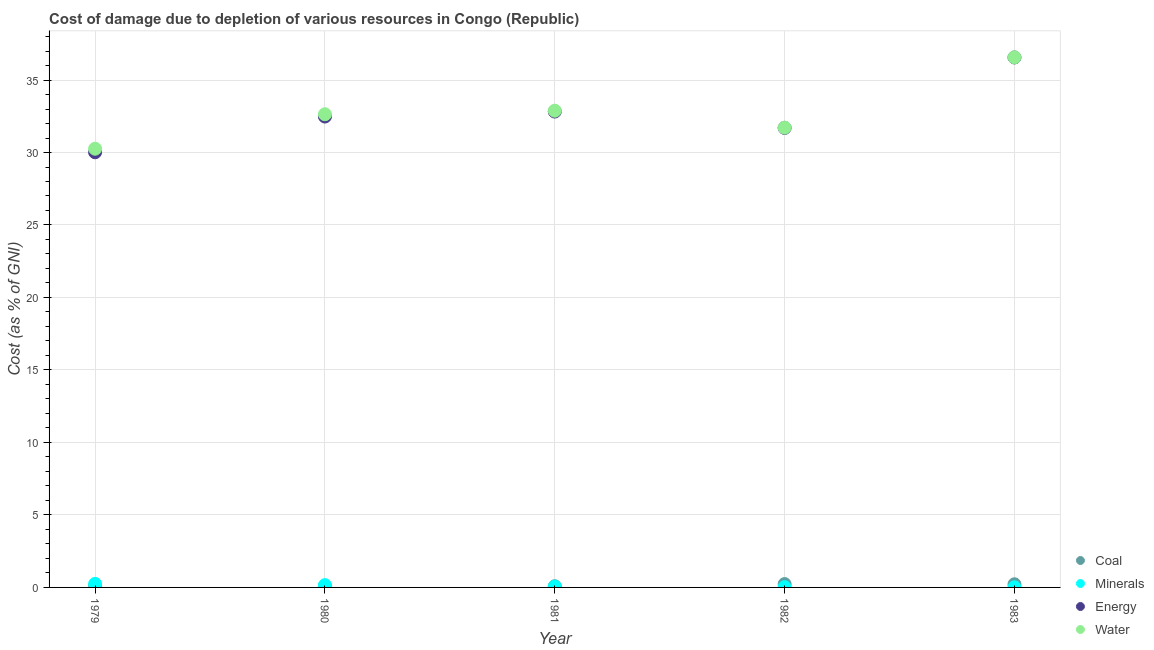What is the cost of damage due to depletion of energy in 1983?
Make the answer very short. 36.56. Across all years, what is the maximum cost of damage due to depletion of water?
Keep it short and to the point. 36.57. Across all years, what is the minimum cost of damage due to depletion of water?
Keep it short and to the point. 30.26. In which year was the cost of damage due to depletion of water minimum?
Ensure brevity in your answer.  1979. What is the total cost of damage due to depletion of coal in the graph?
Give a very brief answer. 0.69. What is the difference between the cost of damage due to depletion of water in 1981 and that in 1983?
Your answer should be compact. -3.68. What is the difference between the cost of damage due to depletion of coal in 1982 and the cost of damage due to depletion of energy in 1981?
Give a very brief answer. -32.59. What is the average cost of damage due to depletion of coal per year?
Provide a short and direct response. 0.14. In the year 1980, what is the difference between the cost of damage due to depletion of minerals and cost of damage due to depletion of coal?
Provide a short and direct response. 0.08. In how many years, is the cost of damage due to depletion of minerals greater than 18 %?
Provide a succinct answer. 0. What is the ratio of the cost of damage due to depletion of energy in 1981 to that in 1983?
Offer a terse response. 0.9. What is the difference between the highest and the second highest cost of damage due to depletion of energy?
Provide a short and direct response. 3.73. What is the difference between the highest and the lowest cost of damage due to depletion of minerals?
Offer a very short reply. 0.23. In how many years, is the cost of damage due to depletion of coal greater than the average cost of damage due to depletion of coal taken over all years?
Offer a very short reply. 2. Is it the case that in every year, the sum of the cost of damage due to depletion of water and cost of damage due to depletion of coal is greater than the sum of cost of damage due to depletion of minerals and cost of damage due to depletion of energy?
Provide a succinct answer. Yes. Is it the case that in every year, the sum of the cost of damage due to depletion of coal and cost of damage due to depletion of minerals is greater than the cost of damage due to depletion of energy?
Provide a succinct answer. No. Is the cost of damage due to depletion of coal strictly greater than the cost of damage due to depletion of energy over the years?
Give a very brief answer. No. How many years are there in the graph?
Ensure brevity in your answer.  5. Are the values on the major ticks of Y-axis written in scientific E-notation?
Keep it short and to the point. No. Where does the legend appear in the graph?
Your response must be concise. Bottom right. How many legend labels are there?
Give a very brief answer. 4. What is the title of the graph?
Ensure brevity in your answer.  Cost of damage due to depletion of various resources in Congo (Republic) . Does "Secondary vocational education" appear as one of the legend labels in the graph?
Provide a succinct answer. No. What is the label or title of the Y-axis?
Your answer should be very brief. Cost (as % of GNI). What is the Cost (as % of GNI) of Coal in 1979?
Give a very brief answer. 0.08. What is the Cost (as % of GNI) in Minerals in 1979?
Your response must be concise. 0.24. What is the Cost (as % of GNI) in Energy in 1979?
Keep it short and to the point. 30.02. What is the Cost (as % of GNI) of Water in 1979?
Ensure brevity in your answer.  30.26. What is the Cost (as % of GNI) in Coal in 1980?
Your answer should be compact. 0.08. What is the Cost (as % of GNI) in Minerals in 1980?
Make the answer very short. 0.16. What is the Cost (as % of GNI) in Energy in 1980?
Make the answer very short. 32.48. What is the Cost (as % of GNI) in Water in 1980?
Your response must be concise. 32.64. What is the Cost (as % of GNI) in Coal in 1981?
Make the answer very short. 0.08. What is the Cost (as % of GNI) of Minerals in 1981?
Keep it short and to the point. 0.06. What is the Cost (as % of GNI) in Energy in 1981?
Offer a very short reply. 32.82. What is the Cost (as % of GNI) of Water in 1981?
Provide a succinct answer. 32.88. What is the Cost (as % of GNI) in Coal in 1982?
Provide a short and direct response. 0.23. What is the Cost (as % of GNI) in Minerals in 1982?
Your answer should be compact. 0.02. What is the Cost (as % of GNI) in Energy in 1982?
Offer a terse response. 31.7. What is the Cost (as % of GNI) of Water in 1982?
Keep it short and to the point. 31.72. What is the Cost (as % of GNI) in Coal in 1983?
Give a very brief answer. 0.22. What is the Cost (as % of GNI) in Minerals in 1983?
Ensure brevity in your answer.  0.01. What is the Cost (as % of GNI) of Energy in 1983?
Provide a short and direct response. 36.56. What is the Cost (as % of GNI) in Water in 1983?
Your answer should be very brief. 36.57. Across all years, what is the maximum Cost (as % of GNI) of Coal?
Ensure brevity in your answer.  0.23. Across all years, what is the maximum Cost (as % of GNI) in Minerals?
Provide a short and direct response. 0.24. Across all years, what is the maximum Cost (as % of GNI) in Energy?
Your answer should be compact. 36.56. Across all years, what is the maximum Cost (as % of GNI) of Water?
Your response must be concise. 36.57. Across all years, what is the minimum Cost (as % of GNI) in Coal?
Your answer should be very brief. 0.08. Across all years, what is the minimum Cost (as % of GNI) of Minerals?
Your answer should be compact. 0.01. Across all years, what is the minimum Cost (as % of GNI) in Energy?
Give a very brief answer. 30.02. Across all years, what is the minimum Cost (as % of GNI) of Water?
Keep it short and to the point. 30.26. What is the total Cost (as % of GNI) in Coal in the graph?
Keep it short and to the point. 0.69. What is the total Cost (as % of GNI) in Minerals in the graph?
Offer a very short reply. 0.49. What is the total Cost (as % of GNI) in Energy in the graph?
Give a very brief answer. 163.57. What is the total Cost (as % of GNI) of Water in the graph?
Your answer should be compact. 164.06. What is the difference between the Cost (as % of GNI) in Coal in 1979 and that in 1980?
Your response must be concise. 0.01. What is the difference between the Cost (as % of GNI) of Minerals in 1979 and that in 1980?
Your answer should be compact. 0.09. What is the difference between the Cost (as % of GNI) in Energy in 1979 and that in 1980?
Your answer should be very brief. -2.46. What is the difference between the Cost (as % of GNI) of Water in 1979 and that in 1980?
Offer a terse response. -2.38. What is the difference between the Cost (as % of GNI) of Coal in 1979 and that in 1981?
Your answer should be very brief. 0. What is the difference between the Cost (as % of GNI) of Minerals in 1979 and that in 1981?
Keep it short and to the point. 0.18. What is the difference between the Cost (as % of GNI) in Energy in 1979 and that in 1981?
Offer a terse response. -2.81. What is the difference between the Cost (as % of GNI) in Water in 1979 and that in 1981?
Provide a succinct answer. -2.62. What is the difference between the Cost (as % of GNI) in Coal in 1979 and that in 1982?
Make the answer very short. -0.15. What is the difference between the Cost (as % of GNI) in Minerals in 1979 and that in 1982?
Your answer should be very brief. 0.22. What is the difference between the Cost (as % of GNI) of Energy in 1979 and that in 1982?
Your response must be concise. -1.68. What is the difference between the Cost (as % of GNI) in Water in 1979 and that in 1982?
Keep it short and to the point. -1.45. What is the difference between the Cost (as % of GNI) in Coal in 1979 and that in 1983?
Make the answer very short. -0.13. What is the difference between the Cost (as % of GNI) of Minerals in 1979 and that in 1983?
Provide a succinct answer. 0.23. What is the difference between the Cost (as % of GNI) of Energy in 1979 and that in 1983?
Provide a succinct answer. -6.54. What is the difference between the Cost (as % of GNI) of Water in 1979 and that in 1983?
Make the answer very short. -6.3. What is the difference between the Cost (as % of GNI) in Coal in 1980 and that in 1981?
Provide a short and direct response. -0. What is the difference between the Cost (as % of GNI) in Minerals in 1980 and that in 1981?
Offer a very short reply. 0.1. What is the difference between the Cost (as % of GNI) of Energy in 1980 and that in 1981?
Offer a very short reply. -0.34. What is the difference between the Cost (as % of GNI) of Water in 1980 and that in 1981?
Make the answer very short. -0.25. What is the difference between the Cost (as % of GNI) in Coal in 1980 and that in 1982?
Give a very brief answer. -0.15. What is the difference between the Cost (as % of GNI) in Minerals in 1980 and that in 1982?
Give a very brief answer. 0.14. What is the difference between the Cost (as % of GNI) of Energy in 1980 and that in 1982?
Your response must be concise. 0.79. What is the difference between the Cost (as % of GNI) in Water in 1980 and that in 1982?
Your response must be concise. 0.92. What is the difference between the Cost (as % of GNI) of Coal in 1980 and that in 1983?
Provide a short and direct response. -0.14. What is the difference between the Cost (as % of GNI) of Minerals in 1980 and that in 1983?
Make the answer very short. 0.15. What is the difference between the Cost (as % of GNI) in Energy in 1980 and that in 1983?
Ensure brevity in your answer.  -4.07. What is the difference between the Cost (as % of GNI) in Water in 1980 and that in 1983?
Make the answer very short. -3.93. What is the difference between the Cost (as % of GNI) of Coal in 1981 and that in 1982?
Provide a short and direct response. -0.15. What is the difference between the Cost (as % of GNI) in Minerals in 1981 and that in 1982?
Offer a terse response. 0.04. What is the difference between the Cost (as % of GNI) of Energy in 1981 and that in 1982?
Your answer should be very brief. 1.13. What is the difference between the Cost (as % of GNI) in Water in 1981 and that in 1982?
Your response must be concise. 1.17. What is the difference between the Cost (as % of GNI) in Coal in 1981 and that in 1983?
Provide a succinct answer. -0.14. What is the difference between the Cost (as % of GNI) of Minerals in 1981 and that in 1983?
Keep it short and to the point. 0.05. What is the difference between the Cost (as % of GNI) of Energy in 1981 and that in 1983?
Your response must be concise. -3.73. What is the difference between the Cost (as % of GNI) in Water in 1981 and that in 1983?
Your answer should be compact. -3.68. What is the difference between the Cost (as % of GNI) of Coal in 1982 and that in 1983?
Provide a short and direct response. 0.01. What is the difference between the Cost (as % of GNI) in Minerals in 1982 and that in 1983?
Keep it short and to the point. 0.01. What is the difference between the Cost (as % of GNI) in Energy in 1982 and that in 1983?
Your answer should be very brief. -4.86. What is the difference between the Cost (as % of GNI) in Water in 1982 and that in 1983?
Your response must be concise. -4.85. What is the difference between the Cost (as % of GNI) in Coal in 1979 and the Cost (as % of GNI) in Minerals in 1980?
Provide a succinct answer. -0.07. What is the difference between the Cost (as % of GNI) in Coal in 1979 and the Cost (as % of GNI) in Energy in 1980?
Make the answer very short. -32.4. What is the difference between the Cost (as % of GNI) in Coal in 1979 and the Cost (as % of GNI) in Water in 1980?
Provide a succinct answer. -32.55. What is the difference between the Cost (as % of GNI) of Minerals in 1979 and the Cost (as % of GNI) of Energy in 1980?
Offer a very short reply. -32.24. What is the difference between the Cost (as % of GNI) of Minerals in 1979 and the Cost (as % of GNI) of Water in 1980?
Make the answer very short. -32.39. What is the difference between the Cost (as % of GNI) of Energy in 1979 and the Cost (as % of GNI) of Water in 1980?
Your answer should be very brief. -2.62. What is the difference between the Cost (as % of GNI) in Coal in 1979 and the Cost (as % of GNI) in Minerals in 1981?
Offer a terse response. 0.02. What is the difference between the Cost (as % of GNI) of Coal in 1979 and the Cost (as % of GNI) of Energy in 1981?
Keep it short and to the point. -32.74. What is the difference between the Cost (as % of GNI) of Coal in 1979 and the Cost (as % of GNI) of Water in 1981?
Offer a very short reply. -32.8. What is the difference between the Cost (as % of GNI) in Minerals in 1979 and the Cost (as % of GNI) in Energy in 1981?
Provide a succinct answer. -32.58. What is the difference between the Cost (as % of GNI) in Minerals in 1979 and the Cost (as % of GNI) in Water in 1981?
Provide a succinct answer. -32.64. What is the difference between the Cost (as % of GNI) in Energy in 1979 and the Cost (as % of GNI) in Water in 1981?
Your response must be concise. -2.87. What is the difference between the Cost (as % of GNI) in Coal in 1979 and the Cost (as % of GNI) in Minerals in 1982?
Your answer should be very brief. 0.06. What is the difference between the Cost (as % of GNI) in Coal in 1979 and the Cost (as % of GNI) in Energy in 1982?
Ensure brevity in your answer.  -31.61. What is the difference between the Cost (as % of GNI) in Coal in 1979 and the Cost (as % of GNI) in Water in 1982?
Give a very brief answer. -31.63. What is the difference between the Cost (as % of GNI) of Minerals in 1979 and the Cost (as % of GNI) of Energy in 1982?
Give a very brief answer. -31.45. What is the difference between the Cost (as % of GNI) in Minerals in 1979 and the Cost (as % of GNI) in Water in 1982?
Your response must be concise. -31.47. What is the difference between the Cost (as % of GNI) in Energy in 1979 and the Cost (as % of GNI) in Water in 1982?
Your response must be concise. -1.7. What is the difference between the Cost (as % of GNI) in Coal in 1979 and the Cost (as % of GNI) in Minerals in 1983?
Your answer should be very brief. 0.07. What is the difference between the Cost (as % of GNI) of Coal in 1979 and the Cost (as % of GNI) of Energy in 1983?
Make the answer very short. -36.47. What is the difference between the Cost (as % of GNI) of Coal in 1979 and the Cost (as % of GNI) of Water in 1983?
Your answer should be compact. -36.48. What is the difference between the Cost (as % of GNI) of Minerals in 1979 and the Cost (as % of GNI) of Energy in 1983?
Offer a terse response. -36.31. What is the difference between the Cost (as % of GNI) of Minerals in 1979 and the Cost (as % of GNI) of Water in 1983?
Offer a very short reply. -36.32. What is the difference between the Cost (as % of GNI) of Energy in 1979 and the Cost (as % of GNI) of Water in 1983?
Your response must be concise. -6.55. What is the difference between the Cost (as % of GNI) in Coal in 1980 and the Cost (as % of GNI) in Minerals in 1981?
Make the answer very short. 0.02. What is the difference between the Cost (as % of GNI) of Coal in 1980 and the Cost (as % of GNI) of Energy in 1981?
Your answer should be compact. -32.75. What is the difference between the Cost (as % of GNI) in Coal in 1980 and the Cost (as % of GNI) in Water in 1981?
Offer a terse response. -32.81. What is the difference between the Cost (as % of GNI) of Minerals in 1980 and the Cost (as % of GNI) of Energy in 1981?
Offer a terse response. -32.67. What is the difference between the Cost (as % of GNI) of Minerals in 1980 and the Cost (as % of GNI) of Water in 1981?
Provide a short and direct response. -32.73. What is the difference between the Cost (as % of GNI) in Energy in 1980 and the Cost (as % of GNI) in Water in 1981?
Offer a terse response. -0.4. What is the difference between the Cost (as % of GNI) in Coal in 1980 and the Cost (as % of GNI) in Minerals in 1982?
Your response must be concise. 0.06. What is the difference between the Cost (as % of GNI) of Coal in 1980 and the Cost (as % of GNI) of Energy in 1982?
Keep it short and to the point. -31.62. What is the difference between the Cost (as % of GNI) in Coal in 1980 and the Cost (as % of GNI) in Water in 1982?
Offer a very short reply. -31.64. What is the difference between the Cost (as % of GNI) in Minerals in 1980 and the Cost (as % of GNI) in Energy in 1982?
Offer a very short reply. -31.54. What is the difference between the Cost (as % of GNI) of Minerals in 1980 and the Cost (as % of GNI) of Water in 1982?
Your answer should be very brief. -31.56. What is the difference between the Cost (as % of GNI) in Energy in 1980 and the Cost (as % of GNI) in Water in 1982?
Give a very brief answer. 0.76. What is the difference between the Cost (as % of GNI) in Coal in 1980 and the Cost (as % of GNI) in Minerals in 1983?
Provide a succinct answer. 0.07. What is the difference between the Cost (as % of GNI) of Coal in 1980 and the Cost (as % of GNI) of Energy in 1983?
Provide a short and direct response. -36.48. What is the difference between the Cost (as % of GNI) in Coal in 1980 and the Cost (as % of GNI) in Water in 1983?
Your answer should be very brief. -36.49. What is the difference between the Cost (as % of GNI) in Minerals in 1980 and the Cost (as % of GNI) in Energy in 1983?
Offer a terse response. -36.4. What is the difference between the Cost (as % of GNI) in Minerals in 1980 and the Cost (as % of GNI) in Water in 1983?
Give a very brief answer. -36.41. What is the difference between the Cost (as % of GNI) in Energy in 1980 and the Cost (as % of GNI) in Water in 1983?
Provide a short and direct response. -4.09. What is the difference between the Cost (as % of GNI) of Coal in 1981 and the Cost (as % of GNI) of Minerals in 1982?
Your answer should be very brief. 0.06. What is the difference between the Cost (as % of GNI) of Coal in 1981 and the Cost (as % of GNI) of Energy in 1982?
Provide a succinct answer. -31.61. What is the difference between the Cost (as % of GNI) in Coal in 1981 and the Cost (as % of GNI) in Water in 1982?
Your response must be concise. -31.63. What is the difference between the Cost (as % of GNI) in Minerals in 1981 and the Cost (as % of GNI) in Energy in 1982?
Offer a very short reply. -31.64. What is the difference between the Cost (as % of GNI) of Minerals in 1981 and the Cost (as % of GNI) of Water in 1982?
Keep it short and to the point. -31.66. What is the difference between the Cost (as % of GNI) of Energy in 1981 and the Cost (as % of GNI) of Water in 1982?
Your response must be concise. 1.11. What is the difference between the Cost (as % of GNI) of Coal in 1981 and the Cost (as % of GNI) of Minerals in 1983?
Your answer should be very brief. 0.07. What is the difference between the Cost (as % of GNI) of Coal in 1981 and the Cost (as % of GNI) of Energy in 1983?
Offer a terse response. -36.47. What is the difference between the Cost (as % of GNI) in Coal in 1981 and the Cost (as % of GNI) in Water in 1983?
Give a very brief answer. -36.48. What is the difference between the Cost (as % of GNI) in Minerals in 1981 and the Cost (as % of GNI) in Energy in 1983?
Give a very brief answer. -36.5. What is the difference between the Cost (as % of GNI) in Minerals in 1981 and the Cost (as % of GNI) in Water in 1983?
Provide a short and direct response. -36.51. What is the difference between the Cost (as % of GNI) in Energy in 1981 and the Cost (as % of GNI) in Water in 1983?
Make the answer very short. -3.74. What is the difference between the Cost (as % of GNI) in Coal in 1982 and the Cost (as % of GNI) in Minerals in 1983?
Give a very brief answer. 0.22. What is the difference between the Cost (as % of GNI) of Coal in 1982 and the Cost (as % of GNI) of Energy in 1983?
Keep it short and to the point. -36.32. What is the difference between the Cost (as % of GNI) in Coal in 1982 and the Cost (as % of GNI) in Water in 1983?
Offer a very short reply. -36.33. What is the difference between the Cost (as % of GNI) of Minerals in 1982 and the Cost (as % of GNI) of Energy in 1983?
Your response must be concise. -36.53. What is the difference between the Cost (as % of GNI) in Minerals in 1982 and the Cost (as % of GNI) in Water in 1983?
Offer a terse response. -36.54. What is the difference between the Cost (as % of GNI) of Energy in 1982 and the Cost (as % of GNI) of Water in 1983?
Offer a terse response. -4.87. What is the average Cost (as % of GNI) of Coal per year?
Offer a very short reply. 0.14. What is the average Cost (as % of GNI) of Minerals per year?
Your answer should be very brief. 0.1. What is the average Cost (as % of GNI) of Energy per year?
Provide a short and direct response. 32.71. What is the average Cost (as % of GNI) of Water per year?
Give a very brief answer. 32.81. In the year 1979, what is the difference between the Cost (as % of GNI) in Coal and Cost (as % of GNI) in Minerals?
Keep it short and to the point. -0.16. In the year 1979, what is the difference between the Cost (as % of GNI) of Coal and Cost (as % of GNI) of Energy?
Your answer should be very brief. -29.93. In the year 1979, what is the difference between the Cost (as % of GNI) of Coal and Cost (as % of GNI) of Water?
Your answer should be very brief. -30.18. In the year 1979, what is the difference between the Cost (as % of GNI) in Minerals and Cost (as % of GNI) in Energy?
Your answer should be very brief. -29.77. In the year 1979, what is the difference between the Cost (as % of GNI) of Minerals and Cost (as % of GNI) of Water?
Give a very brief answer. -30.02. In the year 1979, what is the difference between the Cost (as % of GNI) of Energy and Cost (as % of GNI) of Water?
Your answer should be very brief. -0.24. In the year 1980, what is the difference between the Cost (as % of GNI) of Coal and Cost (as % of GNI) of Minerals?
Your answer should be compact. -0.08. In the year 1980, what is the difference between the Cost (as % of GNI) of Coal and Cost (as % of GNI) of Energy?
Your answer should be compact. -32.4. In the year 1980, what is the difference between the Cost (as % of GNI) of Coal and Cost (as % of GNI) of Water?
Your answer should be very brief. -32.56. In the year 1980, what is the difference between the Cost (as % of GNI) in Minerals and Cost (as % of GNI) in Energy?
Your answer should be very brief. -32.32. In the year 1980, what is the difference between the Cost (as % of GNI) in Minerals and Cost (as % of GNI) in Water?
Provide a short and direct response. -32.48. In the year 1980, what is the difference between the Cost (as % of GNI) in Energy and Cost (as % of GNI) in Water?
Offer a terse response. -0.16. In the year 1981, what is the difference between the Cost (as % of GNI) of Coal and Cost (as % of GNI) of Minerals?
Offer a very short reply. 0.02. In the year 1981, what is the difference between the Cost (as % of GNI) of Coal and Cost (as % of GNI) of Energy?
Provide a short and direct response. -32.74. In the year 1981, what is the difference between the Cost (as % of GNI) of Coal and Cost (as % of GNI) of Water?
Provide a succinct answer. -32.8. In the year 1981, what is the difference between the Cost (as % of GNI) of Minerals and Cost (as % of GNI) of Energy?
Provide a succinct answer. -32.76. In the year 1981, what is the difference between the Cost (as % of GNI) of Minerals and Cost (as % of GNI) of Water?
Your answer should be very brief. -32.82. In the year 1981, what is the difference between the Cost (as % of GNI) of Energy and Cost (as % of GNI) of Water?
Provide a succinct answer. -0.06. In the year 1982, what is the difference between the Cost (as % of GNI) of Coal and Cost (as % of GNI) of Minerals?
Keep it short and to the point. 0.21. In the year 1982, what is the difference between the Cost (as % of GNI) in Coal and Cost (as % of GNI) in Energy?
Keep it short and to the point. -31.46. In the year 1982, what is the difference between the Cost (as % of GNI) of Coal and Cost (as % of GNI) of Water?
Offer a very short reply. -31.48. In the year 1982, what is the difference between the Cost (as % of GNI) of Minerals and Cost (as % of GNI) of Energy?
Provide a short and direct response. -31.67. In the year 1982, what is the difference between the Cost (as % of GNI) in Minerals and Cost (as % of GNI) in Water?
Your answer should be very brief. -31.7. In the year 1982, what is the difference between the Cost (as % of GNI) in Energy and Cost (as % of GNI) in Water?
Keep it short and to the point. -0.02. In the year 1983, what is the difference between the Cost (as % of GNI) of Coal and Cost (as % of GNI) of Minerals?
Your answer should be compact. 0.21. In the year 1983, what is the difference between the Cost (as % of GNI) in Coal and Cost (as % of GNI) in Energy?
Your answer should be compact. -36.34. In the year 1983, what is the difference between the Cost (as % of GNI) in Coal and Cost (as % of GNI) in Water?
Make the answer very short. -36.35. In the year 1983, what is the difference between the Cost (as % of GNI) in Minerals and Cost (as % of GNI) in Energy?
Your answer should be compact. -36.55. In the year 1983, what is the difference between the Cost (as % of GNI) in Minerals and Cost (as % of GNI) in Water?
Offer a terse response. -36.56. In the year 1983, what is the difference between the Cost (as % of GNI) in Energy and Cost (as % of GNI) in Water?
Make the answer very short. -0.01. What is the ratio of the Cost (as % of GNI) in Coal in 1979 to that in 1980?
Ensure brevity in your answer.  1.08. What is the ratio of the Cost (as % of GNI) of Minerals in 1979 to that in 1980?
Offer a terse response. 1.55. What is the ratio of the Cost (as % of GNI) of Energy in 1979 to that in 1980?
Provide a succinct answer. 0.92. What is the ratio of the Cost (as % of GNI) in Water in 1979 to that in 1980?
Your response must be concise. 0.93. What is the ratio of the Cost (as % of GNI) of Coal in 1979 to that in 1981?
Ensure brevity in your answer.  1.03. What is the ratio of the Cost (as % of GNI) in Minerals in 1979 to that in 1981?
Your response must be concise. 4.08. What is the ratio of the Cost (as % of GNI) in Energy in 1979 to that in 1981?
Provide a short and direct response. 0.91. What is the ratio of the Cost (as % of GNI) of Water in 1979 to that in 1981?
Make the answer very short. 0.92. What is the ratio of the Cost (as % of GNI) of Coal in 1979 to that in 1982?
Offer a terse response. 0.36. What is the ratio of the Cost (as % of GNI) of Minerals in 1979 to that in 1982?
Your answer should be very brief. 11.86. What is the ratio of the Cost (as % of GNI) in Energy in 1979 to that in 1982?
Offer a very short reply. 0.95. What is the ratio of the Cost (as % of GNI) of Water in 1979 to that in 1982?
Ensure brevity in your answer.  0.95. What is the ratio of the Cost (as % of GNI) in Coal in 1979 to that in 1983?
Provide a succinct answer. 0.38. What is the ratio of the Cost (as % of GNI) in Minerals in 1979 to that in 1983?
Your answer should be very brief. 23.76. What is the ratio of the Cost (as % of GNI) in Energy in 1979 to that in 1983?
Ensure brevity in your answer.  0.82. What is the ratio of the Cost (as % of GNI) of Water in 1979 to that in 1983?
Your answer should be very brief. 0.83. What is the ratio of the Cost (as % of GNI) in Coal in 1980 to that in 1981?
Provide a short and direct response. 0.95. What is the ratio of the Cost (as % of GNI) of Minerals in 1980 to that in 1981?
Keep it short and to the point. 2.63. What is the ratio of the Cost (as % of GNI) of Water in 1980 to that in 1981?
Make the answer very short. 0.99. What is the ratio of the Cost (as % of GNI) in Coal in 1980 to that in 1982?
Give a very brief answer. 0.33. What is the ratio of the Cost (as % of GNI) of Minerals in 1980 to that in 1982?
Your answer should be compact. 7.65. What is the ratio of the Cost (as % of GNI) of Energy in 1980 to that in 1982?
Keep it short and to the point. 1.02. What is the ratio of the Cost (as % of GNI) in Water in 1980 to that in 1982?
Provide a short and direct response. 1.03. What is the ratio of the Cost (as % of GNI) in Coal in 1980 to that in 1983?
Give a very brief answer. 0.35. What is the ratio of the Cost (as % of GNI) in Minerals in 1980 to that in 1983?
Your answer should be compact. 15.34. What is the ratio of the Cost (as % of GNI) of Energy in 1980 to that in 1983?
Your answer should be compact. 0.89. What is the ratio of the Cost (as % of GNI) of Water in 1980 to that in 1983?
Make the answer very short. 0.89. What is the ratio of the Cost (as % of GNI) in Coal in 1981 to that in 1982?
Make the answer very short. 0.35. What is the ratio of the Cost (as % of GNI) of Minerals in 1981 to that in 1982?
Give a very brief answer. 2.91. What is the ratio of the Cost (as % of GNI) of Energy in 1981 to that in 1982?
Ensure brevity in your answer.  1.04. What is the ratio of the Cost (as % of GNI) in Water in 1981 to that in 1982?
Your answer should be very brief. 1.04. What is the ratio of the Cost (as % of GNI) of Coal in 1981 to that in 1983?
Your answer should be compact. 0.37. What is the ratio of the Cost (as % of GNI) in Minerals in 1981 to that in 1983?
Provide a succinct answer. 5.82. What is the ratio of the Cost (as % of GNI) in Energy in 1981 to that in 1983?
Keep it short and to the point. 0.9. What is the ratio of the Cost (as % of GNI) in Water in 1981 to that in 1983?
Give a very brief answer. 0.9. What is the ratio of the Cost (as % of GNI) of Coal in 1982 to that in 1983?
Provide a succinct answer. 1.06. What is the ratio of the Cost (as % of GNI) in Minerals in 1982 to that in 1983?
Your answer should be compact. 2. What is the ratio of the Cost (as % of GNI) of Energy in 1982 to that in 1983?
Offer a very short reply. 0.87. What is the ratio of the Cost (as % of GNI) in Water in 1982 to that in 1983?
Make the answer very short. 0.87. What is the difference between the highest and the second highest Cost (as % of GNI) of Coal?
Make the answer very short. 0.01. What is the difference between the highest and the second highest Cost (as % of GNI) of Minerals?
Provide a short and direct response. 0.09. What is the difference between the highest and the second highest Cost (as % of GNI) in Energy?
Offer a terse response. 3.73. What is the difference between the highest and the second highest Cost (as % of GNI) in Water?
Ensure brevity in your answer.  3.68. What is the difference between the highest and the lowest Cost (as % of GNI) of Coal?
Offer a very short reply. 0.15. What is the difference between the highest and the lowest Cost (as % of GNI) of Minerals?
Your response must be concise. 0.23. What is the difference between the highest and the lowest Cost (as % of GNI) of Energy?
Give a very brief answer. 6.54. What is the difference between the highest and the lowest Cost (as % of GNI) of Water?
Provide a succinct answer. 6.3. 